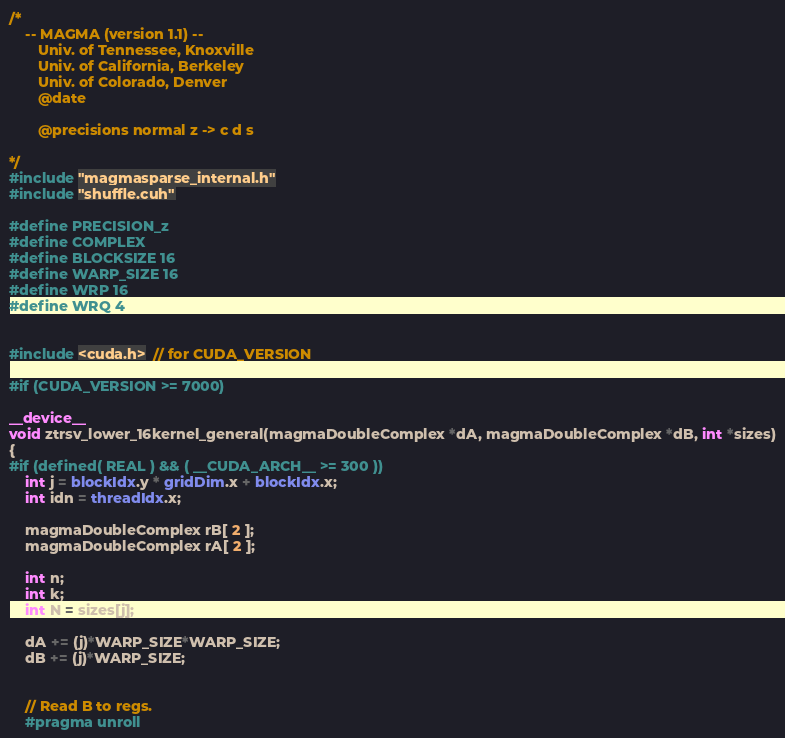<code> <loc_0><loc_0><loc_500><loc_500><_Cuda_>/*
    -- MAGMA (version 1.1) --
       Univ. of Tennessee, Knoxville
       Univ. of California, Berkeley
       Univ. of Colorado, Denver
       @date

       @precisions normal z -> c d s

*/
#include "magmasparse_internal.h"
#include "shuffle.cuh"

#define PRECISION_z
#define COMPLEX
#define BLOCKSIZE 16
#define WARP_SIZE 16
#define WRP 16
#define WRQ 4


#include <cuda.h>  // for CUDA_VERSION

#if (CUDA_VERSION >= 7000)

__device__
void ztrsv_lower_16kernel_general(magmaDoubleComplex *dA, magmaDoubleComplex *dB, int *sizes)
{
#if (defined( REAL ) && ( __CUDA_ARCH__ >= 300 ))
    int j = blockIdx.y * gridDim.x + blockIdx.x;
    int idn = threadIdx.x;

    magmaDoubleComplex rB[ 2 ];
    magmaDoubleComplex rA[ 2 ];

    int n;
    int k;
    int N = sizes[j];

    dA += (j)*WARP_SIZE*WARP_SIZE;
    dB += (j)*WARP_SIZE;


    // Read B to regs.
    #pragma unroll</code> 